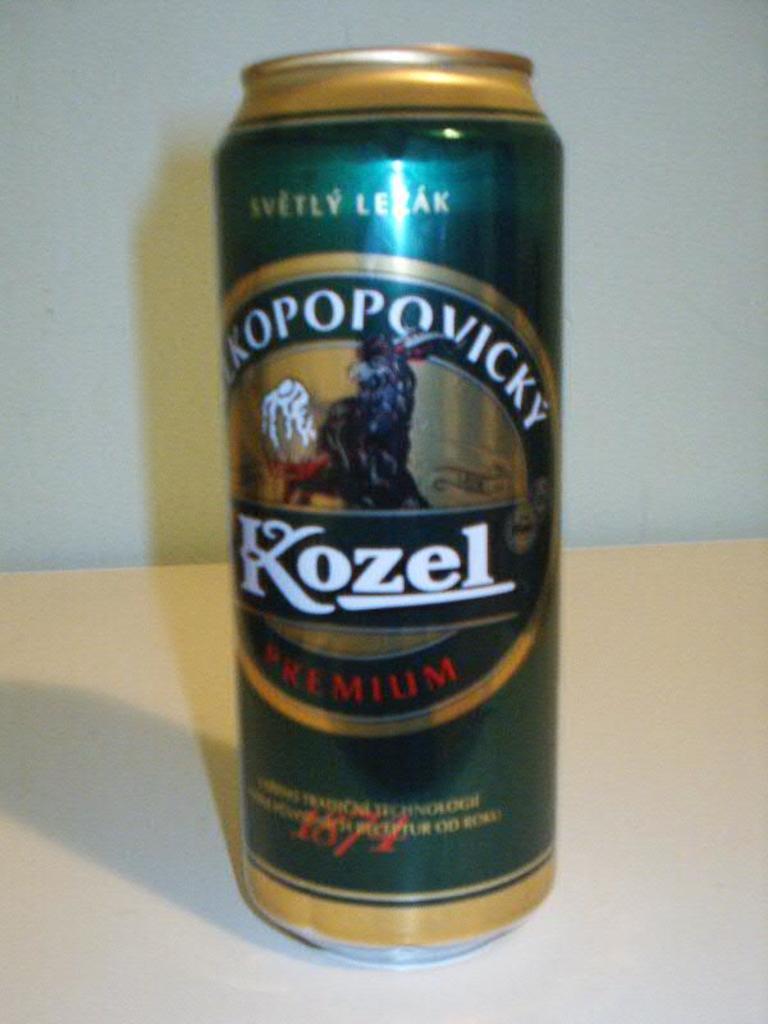What brand name is on the beer can?
Keep it short and to the point. Kozel. What year was this company founded?
Ensure brevity in your answer.  1874. 